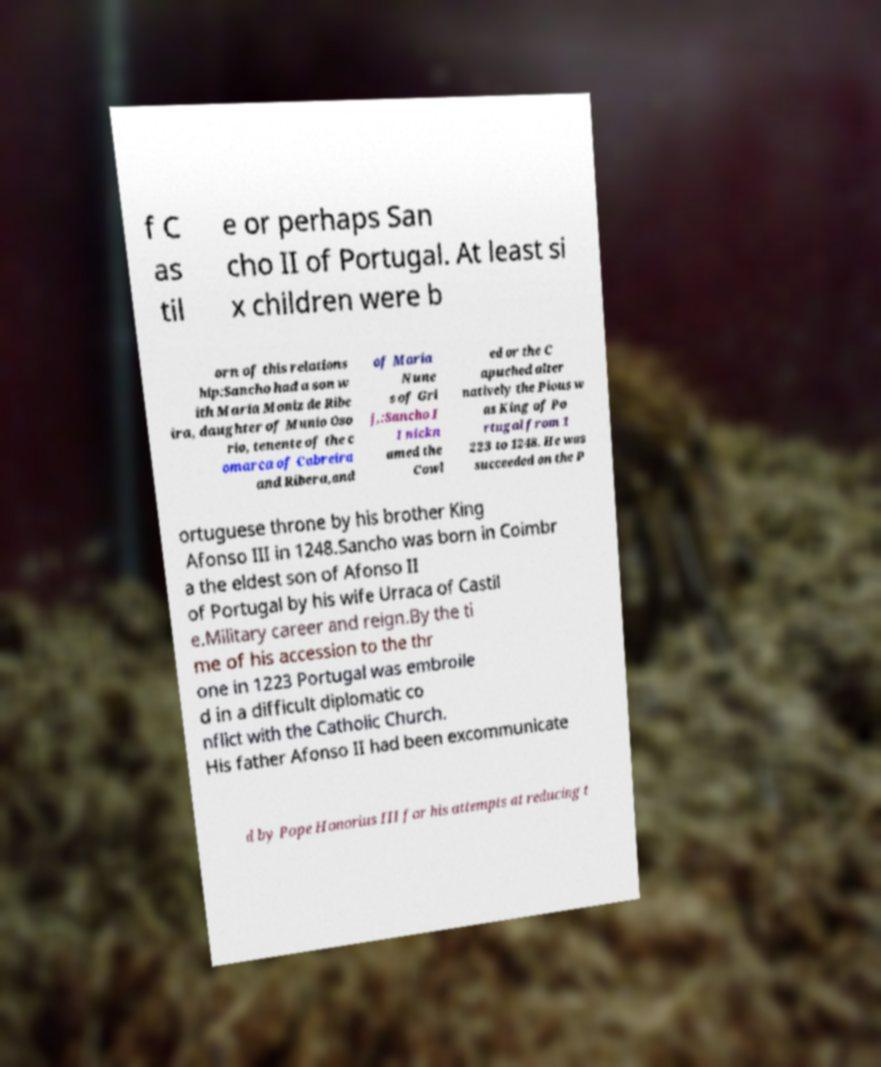Could you assist in decoding the text presented in this image and type it out clearly? f C as til e or perhaps San cho II of Portugal. At least si x children were b orn of this relations hip:Sancho had a son w ith Maria Moniz de Ribe ira, daughter of Munio Oso rio, tenente of the c omarca of Cabreira and Ribera,and of Maria Nune s of Gri j,:Sancho I I nickn amed the Cowl ed or the C apuched alter natively the Pious w as King of Po rtugal from 1 223 to 1248. He was succeeded on the P ortuguese throne by his brother King Afonso III in 1248.Sancho was born in Coimbr a the eldest son of Afonso II of Portugal by his wife Urraca of Castil e.Military career and reign.By the ti me of his accession to the thr one in 1223 Portugal was embroile d in a difficult diplomatic co nflict with the Catholic Church. His father Afonso II had been excommunicate d by Pope Honorius III for his attempts at reducing t 